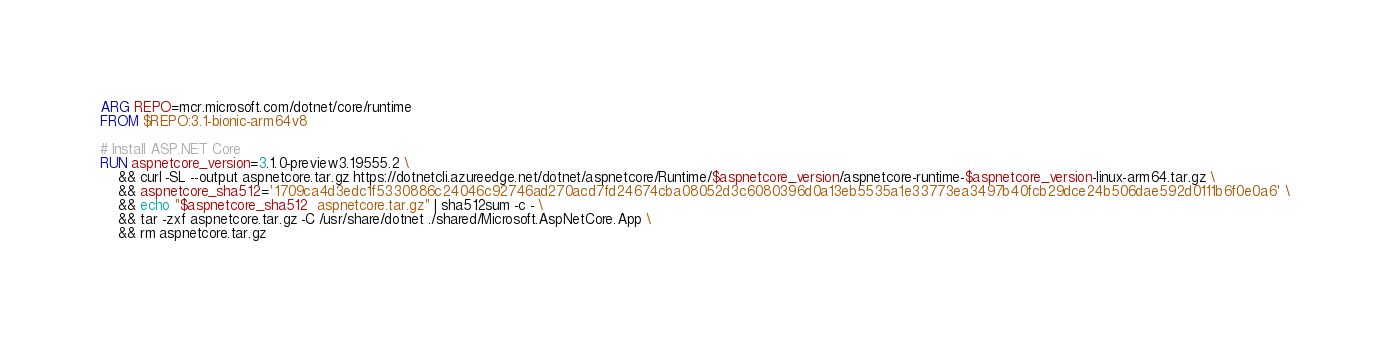<code> <loc_0><loc_0><loc_500><loc_500><_Dockerfile_>ARG REPO=mcr.microsoft.com/dotnet/core/runtime
FROM $REPO:3.1-bionic-arm64v8

# Install ASP.NET Core
RUN aspnetcore_version=3.1.0-preview3.19555.2 \
    && curl -SL --output aspnetcore.tar.gz https://dotnetcli.azureedge.net/dotnet/aspnetcore/Runtime/$aspnetcore_version/aspnetcore-runtime-$aspnetcore_version-linux-arm64.tar.gz \
    && aspnetcore_sha512='1709ca4d3edc1f5330886c24046c92746ad270acd7fd24674cba08052d3c6080396d0a13eb5535a1e33773ea3497b40fcb29dce24b506dae592d0111b6f0e0a6' \
    && echo "$aspnetcore_sha512  aspnetcore.tar.gz" | sha512sum -c - \
    && tar -zxf aspnetcore.tar.gz -C /usr/share/dotnet ./shared/Microsoft.AspNetCore.App \
    && rm aspnetcore.tar.gz
</code> 